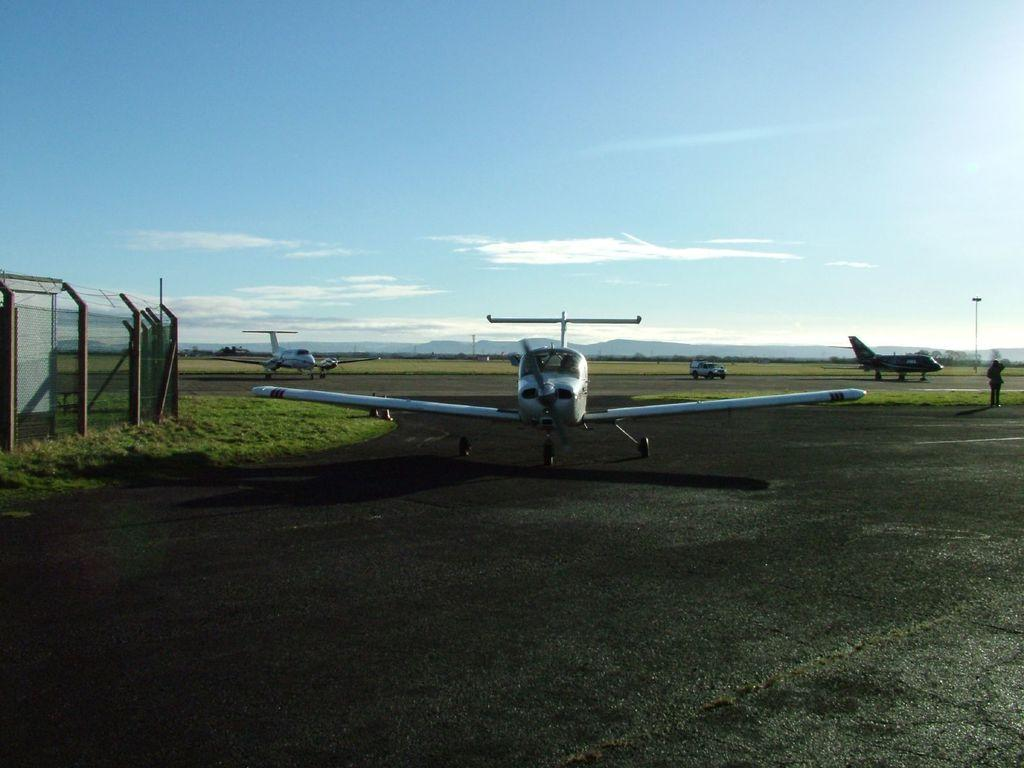What is the main subject of the image? The main subject of the image is airplanes on a runway. What can be seen on the left side of the image? There is fencing on the left side of the image. What is visible in the background of the image? The sky is visible in the background of the image. Can you describe the person on the right side of the image? There is a man standing on the right side of the image. How many women are wearing hats in the image? There are no women or hats present in the image. 